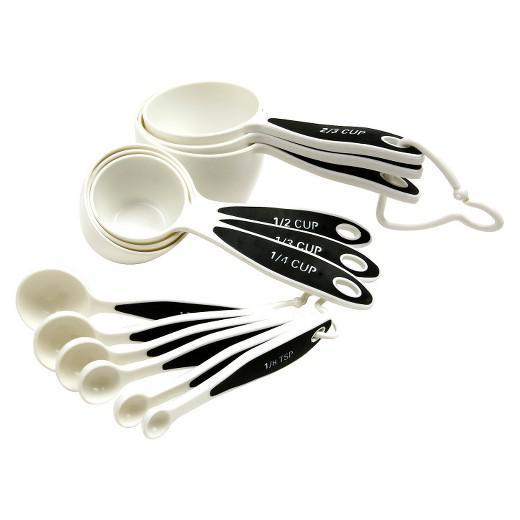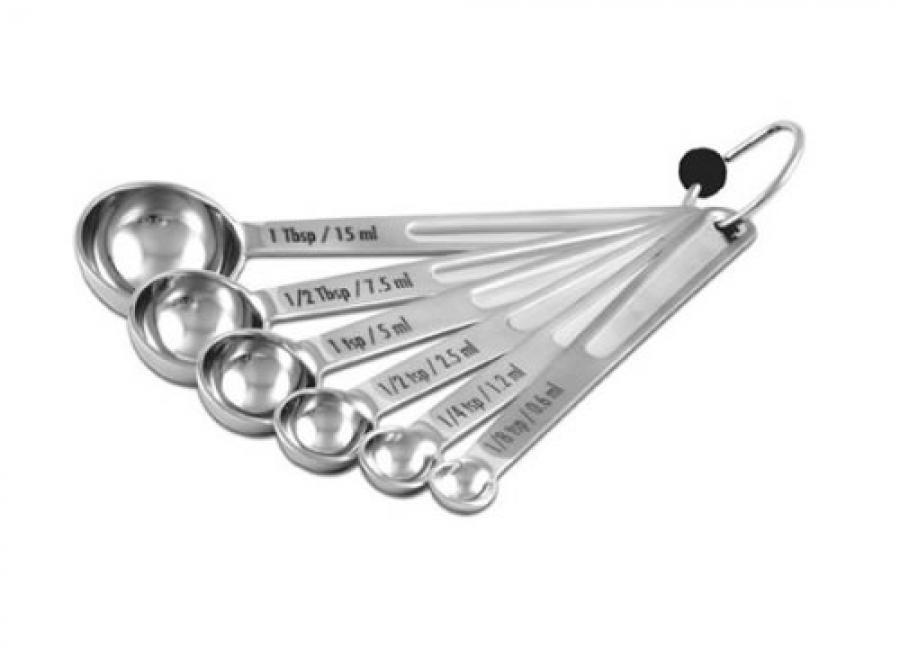The first image is the image on the left, the second image is the image on the right. For the images shown, is this caption "The right image shows only one set of measuring utensils joined together." true? Answer yes or no. Yes. 